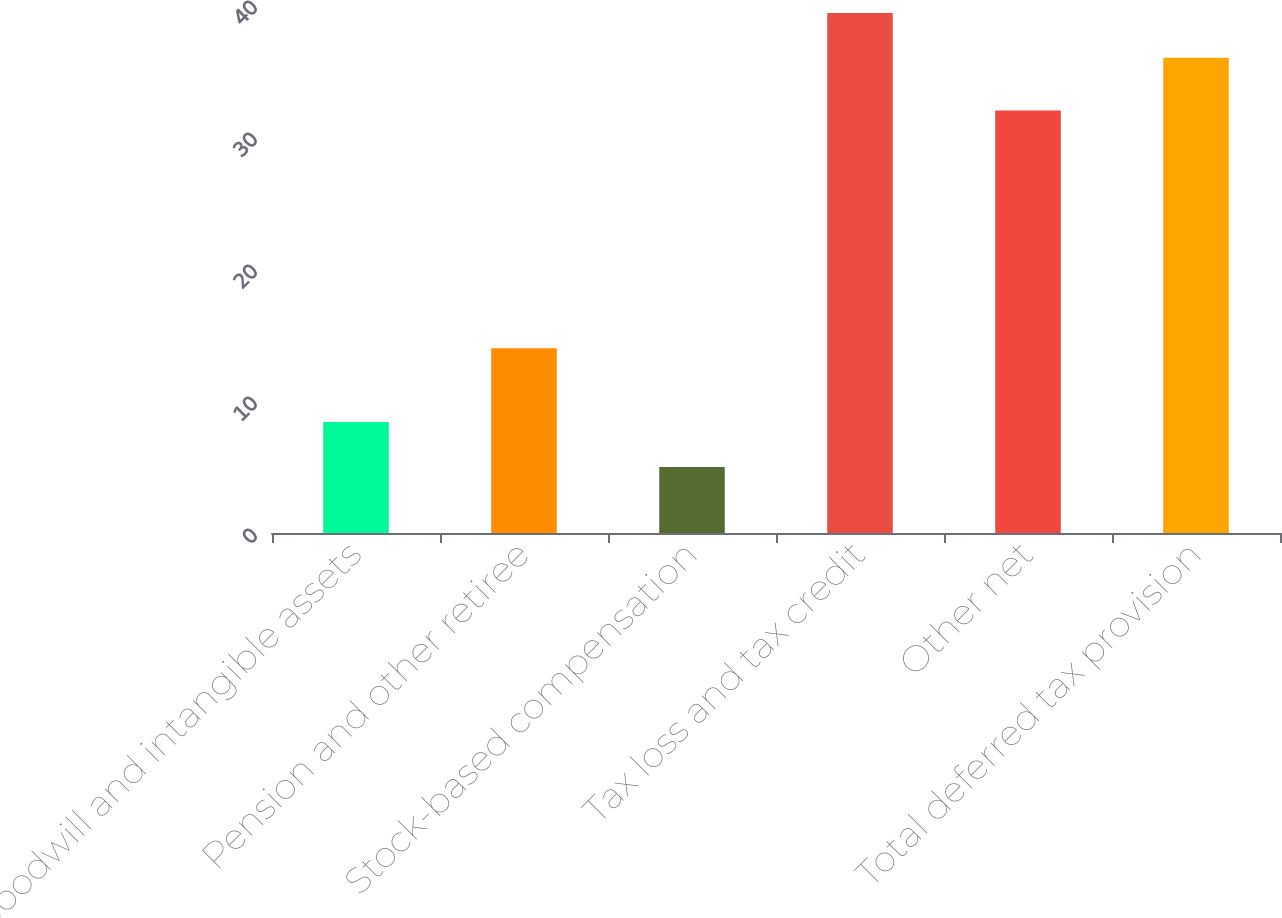<chart> <loc_0><loc_0><loc_500><loc_500><bar_chart><fcel>Goodwill and intangible assets<fcel>Pension and other retiree<fcel>Stock-based compensation<fcel>Tax loss and tax credit<fcel>Other net<fcel>Total deferred tax provision<nl><fcel>8.4<fcel>14<fcel>5<fcel>39.4<fcel>32<fcel>36<nl></chart> 